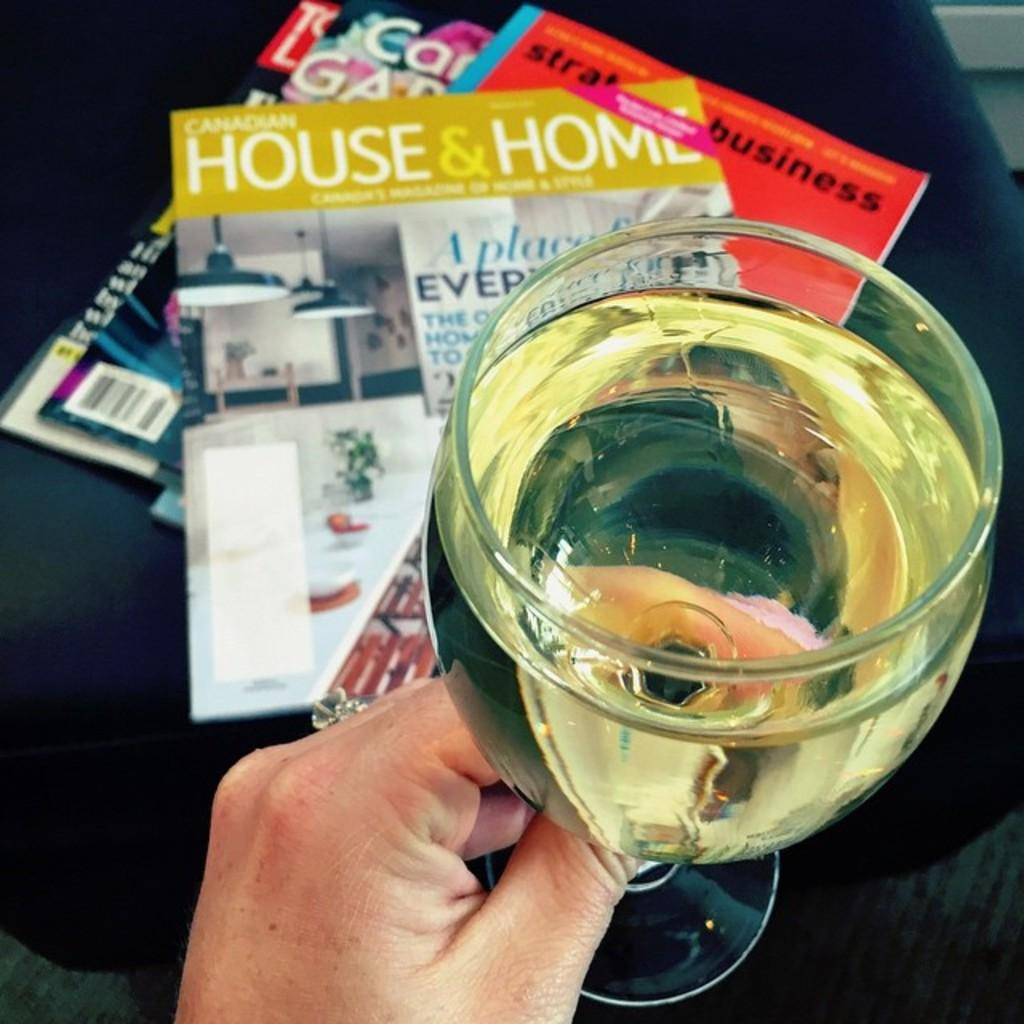<image>
Provide a brief description of the given image. a full glass of white wine held above magazines like House & Home 